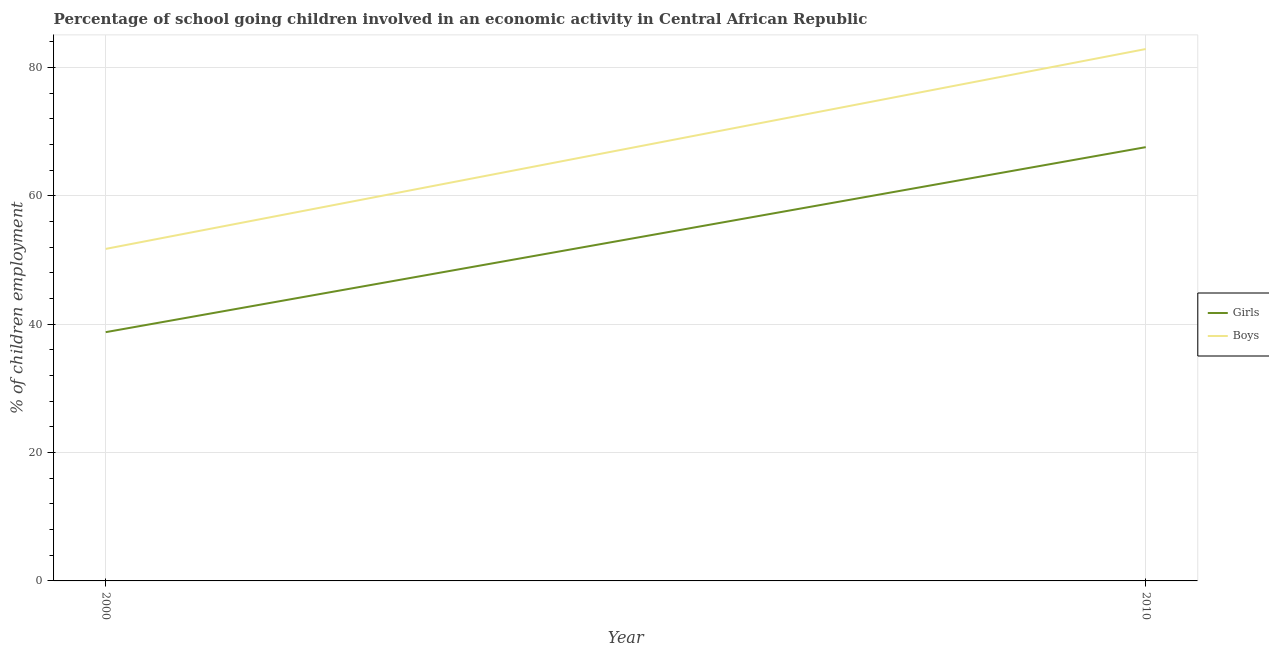Is the number of lines equal to the number of legend labels?
Your response must be concise. Yes. What is the percentage of school going boys in 2010?
Provide a succinct answer. 82.87. Across all years, what is the maximum percentage of school going boys?
Offer a terse response. 82.87. Across all years, what is the minimum percentage of school going girls?
Provide a short and direct response. 38.76. In which year was the percentage of school going boys minimum?
Offer a terse response. 2000. What is the total percentage of school going girls in the graph?
Give a very brief answer. 106.34. What is the difference between the percentage of school going boys in 2000 and that in 2010?
Provide a short and direct response. -31.14. What is the difference between the percentage of school going boys in 2010 and the percentage of school going girls in 2000?
Your answer should be compact. 44.11. What is the average percentage of school going boys per year?
Give a very brief answer. 67.3. In the year 2010, what is the difference between the percentage of school going boys and percentage of school going girls?
Give a very brief answer. 15.29. In how many years, is the percentage of school going boys greater than 68 %?
Provide a short and direct response. 1. What is the ratio of the percentage of school going girls in 2000 to that in 2010?
Offer a very short reply. 0.57. Is the percentage of school going boys in 2000 less than that in 2010?
Offer a terse response. Yes. Does the percentage of school going boys monotonically increase over the years?
Keep it short and to the point. Yes. Is the percentage of school going boys strictly less than the percentage of school going girls over the years?
Your response must be concise. No. What is the difference between two consecutive major ticks on the Y-axis?
Your answer should be compact. 20. Are the values on the major ticks of Y-axis written in scientific E-notation?
Provide a succinct answer. No. What is the title of the graph?
Provide a short and direct response. Percentage of school going children involved in an economic activity in Central African Republic. What is the label or title of the X-axis?
Your answer should be very brief. Year. What is the label or title of the Y-axis?
Offer a very short reply. % of children employment. What is the % of children employment in Girls in 2000?
Offer a very short reply. 38.76. What is the % of children employment of Boys in 2000?
Ensure brevity in your answer.  51.73. What is the % of children employment in Girls in 2010?
Your answer should be compact. 67.58. What is the % of children employment of Boys in 2010?
Make the answer very short. 82.87. Across all years, what is the maximum % of children employment of Girls?
Your answer should be very brief. 67.58. Across all years, what is the maximum % of children employment of Boys?
Make the answer very short. 82.87. Across all years, what is the minimum % of children employment in Girls?
Give a very brief answer. 38.76. Across all years, what is the minimum % of children employment in Boys?
Make the answer very short. 51.73. What is the total % of children employment of Girls in the graph?
Your response must be concise. 106.34. What is the total % of children employment of Boys in the graph?
Ensure brevity in your answer.  134.6. What is the difference between the % of children employment in Girls in 2000 and that in 2010?
Your answer should be very brief. -28.82. What is the difference between the % of children employment in Boys in 2000 and that in 2010?
Ensure brevity in your answer.  -31.14. What is the difference between the % of children employment of Girls in 2000 and the % of children employment of Boys in 2010?
Provide a succinct answer. -44.11. What is the average % of children employment in Girls per year?
Make the answer very short. 53.17. What is the average % of children employment in Boys per year?
Give a very brief answer. 67.3. In the year 2000, what is the difference between the % of children employment in Girls and % of children employment in Boys?
Provide a short and direct response. -12.97. In the year 2010, what is the difference between the % of children employment in Girls and % of children employment in Boys?
Provide a short and direct response. -15.29. What is the ratio of the % of children employment in Girls in 2000 to that in 2010?
Offer a terse response. 0.57. What is the ratio of the % of children employment of Boys in 2000 to that in 2010?
Keep it short and to the point. 0.62. What is the difference between the highest and the second highest % of children employment in Girls?
Offer a terse response. 28.82. What is the difference between the highest and the second highest % of children employment of Boys?
Ensure brevity in your answer.  31.14. What is the difference between the highest and the lowest % of children employment in Girls?
Provide a short and direct response. 28.82. What is the difference between the highest and the lowest % of children employment of Boys?
Keep it short and to the point. 31.14. 